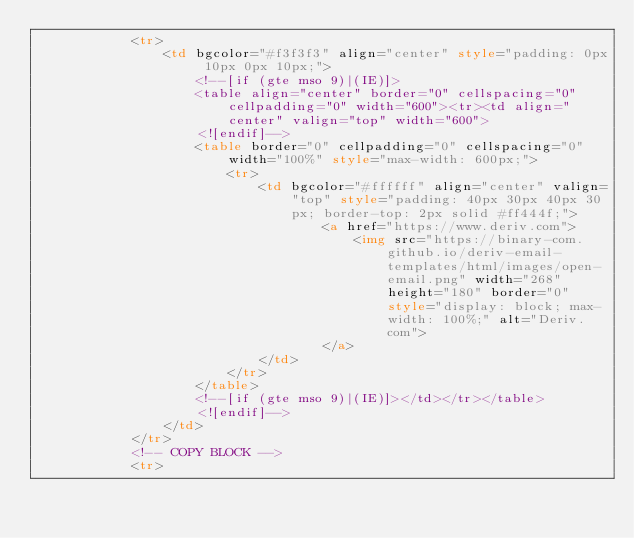Convert code to text. <code><loc_0><loc_0><loc_500><loc_500><_HTML_>            <tr>
                <td bgcolor="#f3f3f3" align="center" style="padding: 0px 10px 0px 10px;">
                    <!--[if (gte mso 9)|(IE)]>
                    <table align="center" border="0" cellspacing="0" cellpadding="0" width="600"><tr><td align="center" valign="top" width="600">
                    <![endif]-->
                    <table border="0" cellpadding="0" cellspacing="0" width="100%" style="max-width: 600px;">
                        <tr>
                            <td bgcolor="#ffffff" align="center" valign="top" style="padding: 40px 30px 40px 30px; border-top: 2px solid #ff444f;">
                                    <a href="https://www.deriv.com">
                                        <img src="https://binary-com.github.io/deriv-email-templates/html/images/open-email.png" width="268" height="180" border="0" style="display: block; max-width: 100%;" alt="Deriv.com">
                                    </a>
                            </td>
                        </tr>
                    </table>
                    <!--[if (gte mso 9)|(IE)]></td></tr></table>
                    <![endif]-->
                </td>
            </tr>
            <!-- COPY BLOCK -->
            <tr></code> 